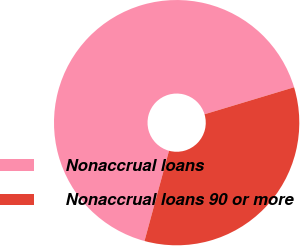Convert chart. <chart><loc_0><loc_0><loc_500><loc_500><pie_chart><fcel>Nonaccrual loans<fcel>Nonaccrual loans 90 or more<nl><fcel>66.12%<fcel>33.88%<nl></chart> 